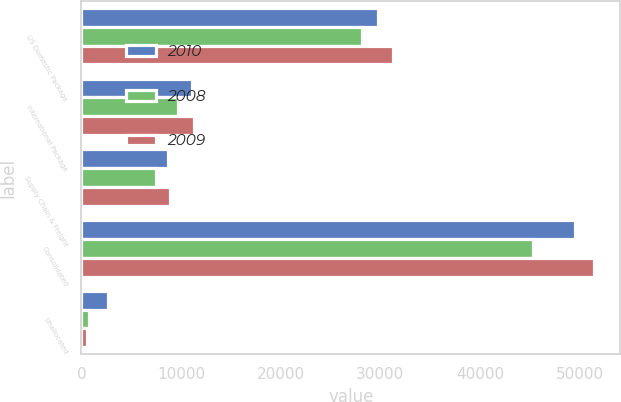<chart> <loc_0><loc_0><loc_500><loc_500><stacked_bar_chart><ecel><fcel>US Domestic Package<fcel>International Package<fcel>Supply Chain & Freight<fcel>Consolidated<fcel>Unallocated<nl><fcel>2010<fcel>29742<fcel>11133<fcel>8670<fcel>49545<fcel>2661<nl><fcel>2008<fcel>28158<fcel>9699<fcel>7440<fcel>45297<fcel>809<nl><fcel>2009<fcel>31278<fcel>11293<fcel>8915<fcel>51486<fcel>585<nl></chart> 